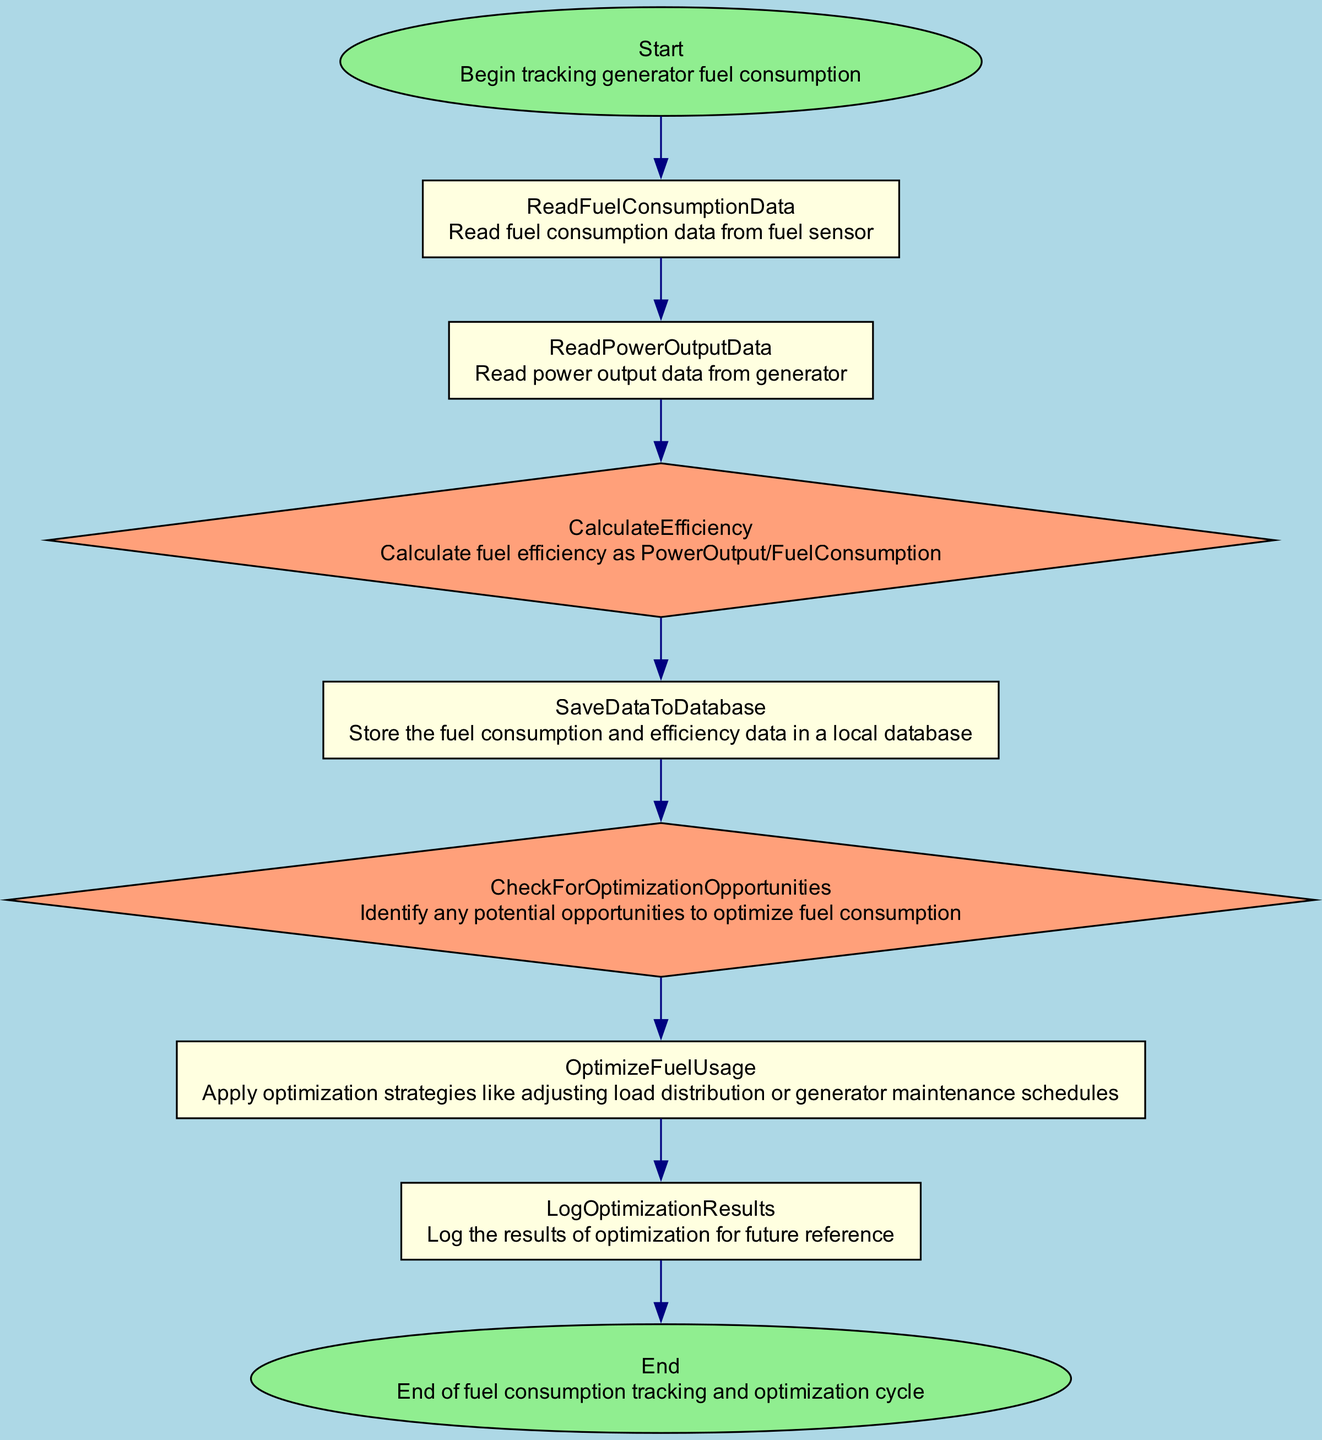What is the first step in the flowchart? The first step described in the flowchart is labeled as "Start," which indicates the beginning of the fuel consumption tracking process.
Answer: Start How many steps are in the flowchart? By counting all the steps listed, there are a total of nine steps in the flowchart from Start to End.
Answer: Nine What type of node is 'CalculateEfficiency'? 'CalculateEfficiency' is a diamond-shaped node, which signifies a decision or calculation in the flow of the process.
Answer: Diamond Which step comes after 'SaveDataToDatabase'? The step that follows 'SaveDataToDatabase' is 'CheckForOptimizationOpportunities,' indicating a progression towards identifying optimization potentials.
Answer: CheckForOptimizationOpportunities What is the last step of the flowchart? The final step in the flowchart is labeled as 'End,' marking the conclusion of the fuel consumption tracking and optimization cycle.
Answer: End Explain the relationship between 'ReadFuelConsumptionData' and 'CalculateEfficiency'. 'ReadFuelConsumptionData' provides the necessary fuel consumption data, which is then used in the 'CalculateEfficiency' step to determine how efficiently fuel is being consumed based on the power output.
Answer: Fuel data → Efficiency calculation What is the purpose of the 'LogOptimizationResults' step? The 'LogOptimizationResults' step serves the purpose of recording the outcomes of any optimization strategies applied, allowing for future reference and analysis of effectiveness.
Answer: Record optimization outcomes Which step involves adjusting load distribution? The step that involves adjusting load distribution is 'OptimizeFuelUsage,' where strategies like load distribution adjustments are discussed to enhance fuel usage efficiency.
Answer: OptimizeFuelUsage How many decision nodes are present in the flowchart? There are three decision nodes in the flowchart: ‘CalculateEfficiency,’ ‘CheckForOptimizationOpportunities,’ and ‘OptimizeFuelUsage.’
Answer: Three 